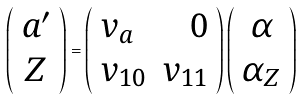Convert formula to latex. <formula><loc_0><loc_0><loc_500><loc_500>\left ( \begin{array} { c } a ^ { \prime } \\ Z \end{array} \right ) = \left ( \begin{array} { l r } v _ { a } & 0 \\ v _ { 1 0 } & v _ { 1 1 } \end{array} \right ) \left ( \begin{array} { c } \alpha \\ \alpha _ { Z } \end{array} \right )</formula> 